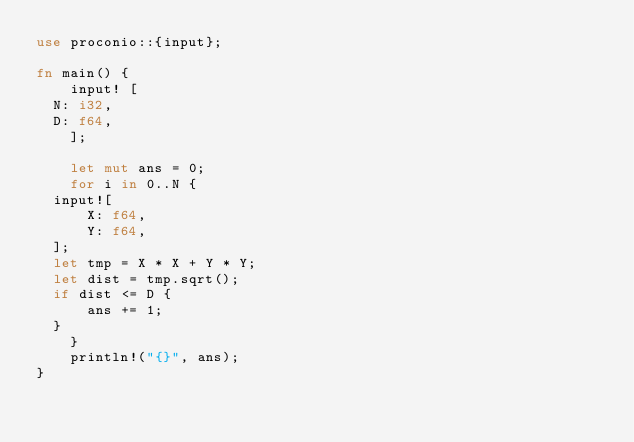<code> <loc_0><loc_0><loc_500><loc_500><_Rust_>use proconio::{input};

fn main() {
    input! [
	N: i32,
	D: f64,
    ];

    let mut ans = 0;
    for i in 0..N {
	input![
	    X: f64,
	    Y: f64,
	];
	let tmp = X * X + Y * Y;
	let dist = tmp.sqrt();
	if dist <= D {
	    ans += 1;
	}
    }
    println!("{}", ans);
}
</code> 